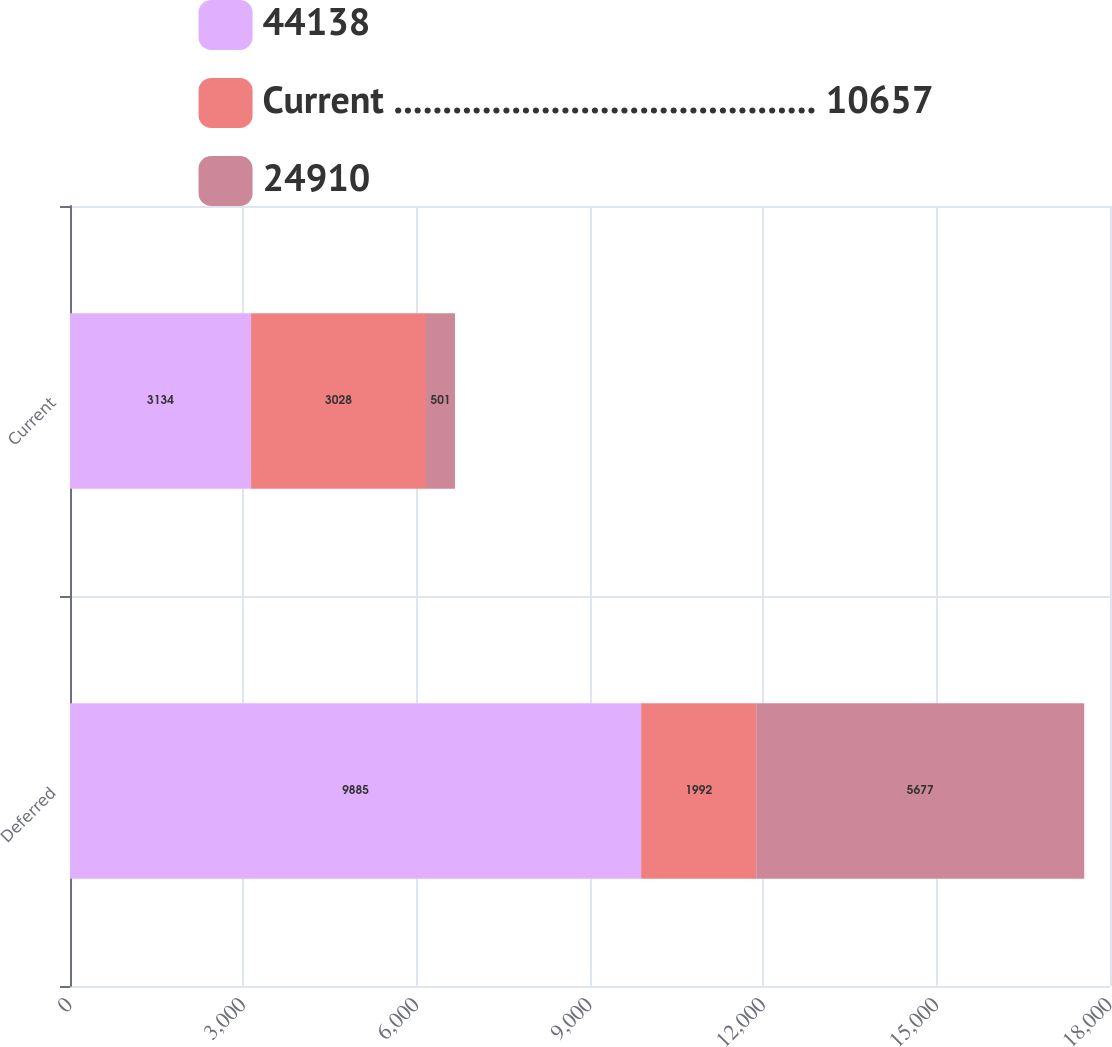Convert chart to OTSL. <chart><loc_0><loc_0><loc_500><loc_500><stacked_bar_chart><ecel><fcel>Deferred<fcel>Current<nl><fcel>44138<fcel>9885<fcel>3134<nl><fcel>Current ........................................... 10657<fcel>1992<fcel>3028<nl><fcel>24910<fcel>5677<fcel>501<nl></chart> 